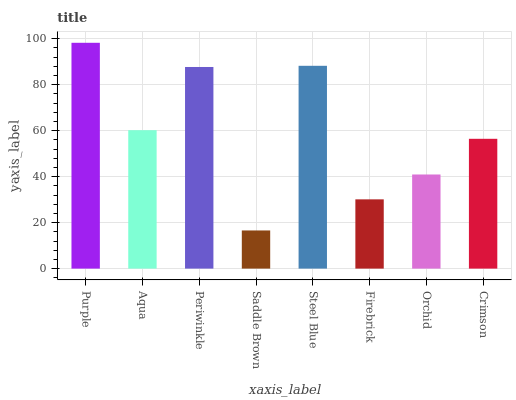Is Saddle Brown the minimum?
Answer yes or no. Yes. Is Purple the maximum?
Answer yes or no. Yes. Is Aqua the minimum?
Answer yes or no. No. Is Aqua the maximum?
Answer yes or no. No. Is Purple greater than Aqua?
Answer yes or no. Yes. Is Aqua less than Purple?
Answer yes or no. Yes. Is Aqua greater than Purple?
Answer yes or no. No. Is Purple less than Aqua?
Answer yes or no. No. Is Aqua the high median?
Answer yes or no. Yes. Is Crimson the low median?
Answer yes or no. Yes. Is Crimson the high median?
Answer yes or no. No. Is Saddle Brown the low median?
Answer yes or no. No. 